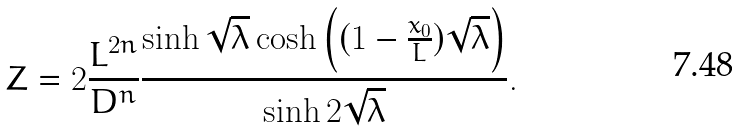Convert formula to latex. <formula><loc_0><loc_0><loc_500><loc_500>Z = 2 \frac { L ^ { 2 n } } { D ^ { n } } \frac { \sinh \sqrt { \lambda } \cosh \left ( ( 1 - \frac { x _ { 0 } } { L } ) \sqrt { \lambda } \right ) } { \sinh 2 \sqrt { \lambda } } .</formula> 